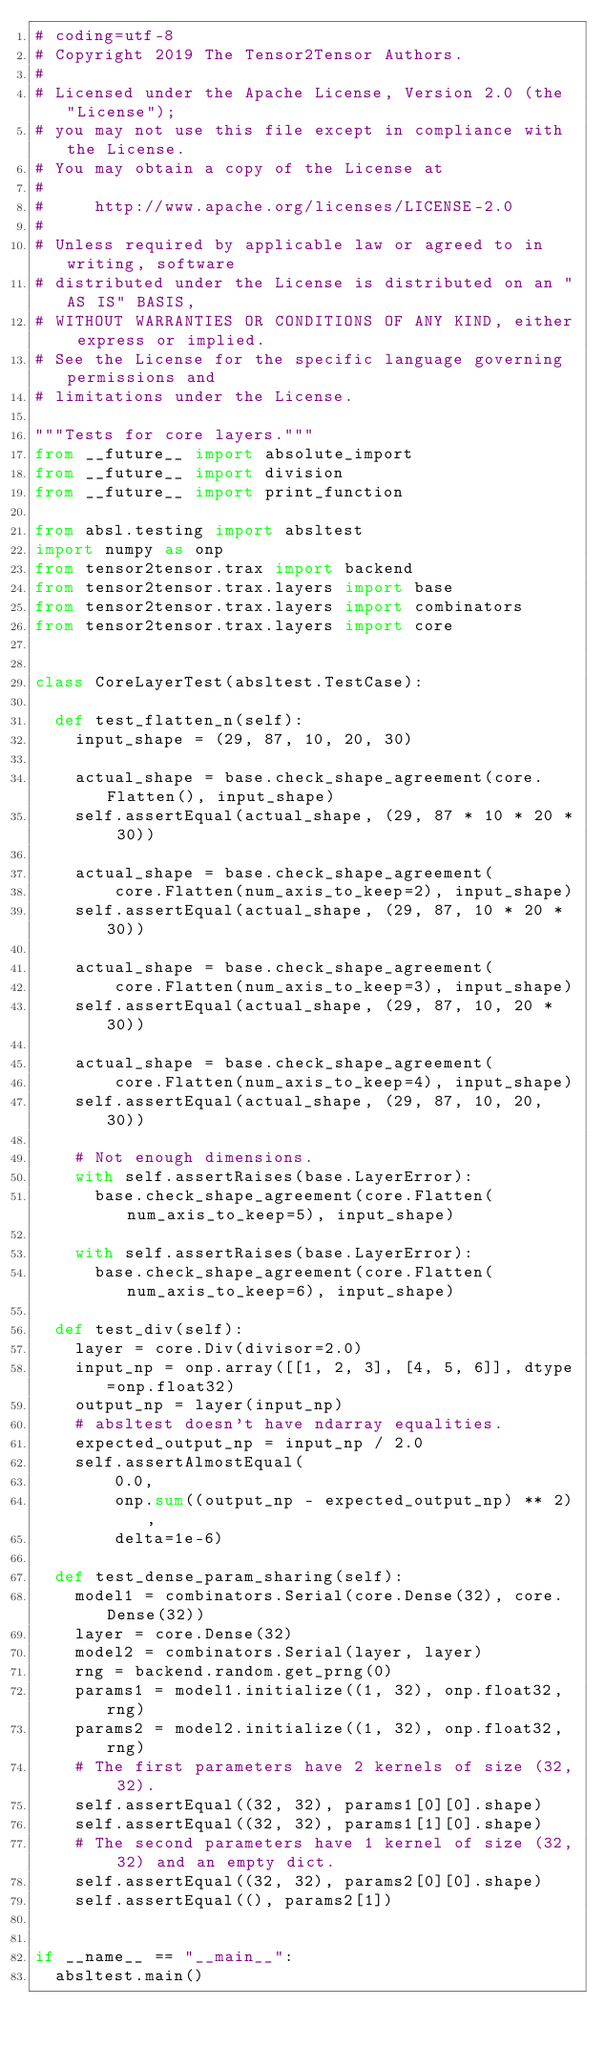Convert code to text. <code><loc_0><loc_0><loc_500><loc_500><_Python_># coding=utf-8
# Copyright 2019 The Tensor2Tensor Authors.
#
# Licensed under the Apache License, Version 2.0 (the "License");
# you may not use this file except in compliance with the License.
# You may obtain a copy of the License at
#
#     http://www.apache.org/licenses/LICENSE-2.0
#
# Unless required by applicable law or agreed to in writing, software
# distributed under the License is distributed on an "AS IS" BASIS,
# WITHOUT WARRANTIES OR CONDITIONS OF ANY KIND, either express or implied.
# See the License for the specific language governing permissions and
# limitations under the License.

"""Tests for core layers."""
from __future__ import absolute_import
from __future__ import division
from __future__ import print_function

from absl.testing import absltest
import numpy as onp
from tensor2tensor.trax import backend
from tensor2tensor.trax.layers import base
from tensor2tensor.trax.layers import combinators
from tensor2tensor.trax.layers import core


class CoreLayerTest(absltest.TestCase):

  def test_flatten_n(self):
    input_shape = (29, 87, 10, 20, 30)

    actual_shape = base.check_shape_agreement(core.Flatten(), input_shape)
    self.assertEqual(actual_shape, (29, 87 * 10 * 20 * 30))

    actual_shape = base.check_shape_agreement(
        core.Flatten(num_axis_to_keep=2), input_shape)
    self.assertEqual(actual_shape, (29, 87, 10 * 20 * 30))

    actual_shape = base.check_shape_agreement(
        core.Flatten(num_axis_to_keep=3), input_shape)
    self.assertEqual(actual_shape, (29, 87, 10, 20 * 30))

    actual_shape = base.check_shape_agreement(
        core.Flatten(num_axis_to_keep=4), input_shape)
    self.assertEqual(actual_shape, (29, 87, 10, 20, 30))

    # Not enough dimensions.
    with self.assertRaises(base.LayerError):
      base.check_shape_agreement(core.Flatten(num_axis_to_keep=5), input_shape)

    with self.assertRaises(base.LayerError):
      base.check_shape_agreement(core.Flatten(num_axis_to_keep=6), input_shape)

  def test_div(self):
    layer = core.Div(divisor=2.0)
    input_np = onp.array([[1, 2, 3], [4, 5, 6]], dtype=onp.float32)
    output_np = layer(input_np)
    # absltest doesn't have ndarray equalities.
    expected_output_np = input_np / 2.0
    self.assertAlmostEqual(
        0.0,
        onp.sum((output_np - expected_output_np) ** 2),
        delta=1e-6)

  def test_dense_param_sharing(self):
    model1 = combinators.Serial(core.Dense(32), core.Dense(32))
    layer = core.Dense(32)
    model2 = combinators.Serial(layer, layer)
    rng = backend.random.get_prng(0)
    params1 = model1.initialize((1, 32), onp.float32, rng)
    params2 = model2.initialize((1, 32), onp.float32, rng)
    # The first parameters have 2 kernels of size (32, 32).
    self.assertEqual((32, 32), params1[0][0].shape)
    self.assertEqual((32, 32), params1[1][0].shape)
    # The second parameters have 1 kernel of size (32, 32) and an empty dict.
    self.assertEqual((32, 32), params2[0][0].shape)
    self.assertEqual((), params2[1])


if __name__ == "__main__":
  absltest.main()
</code> 